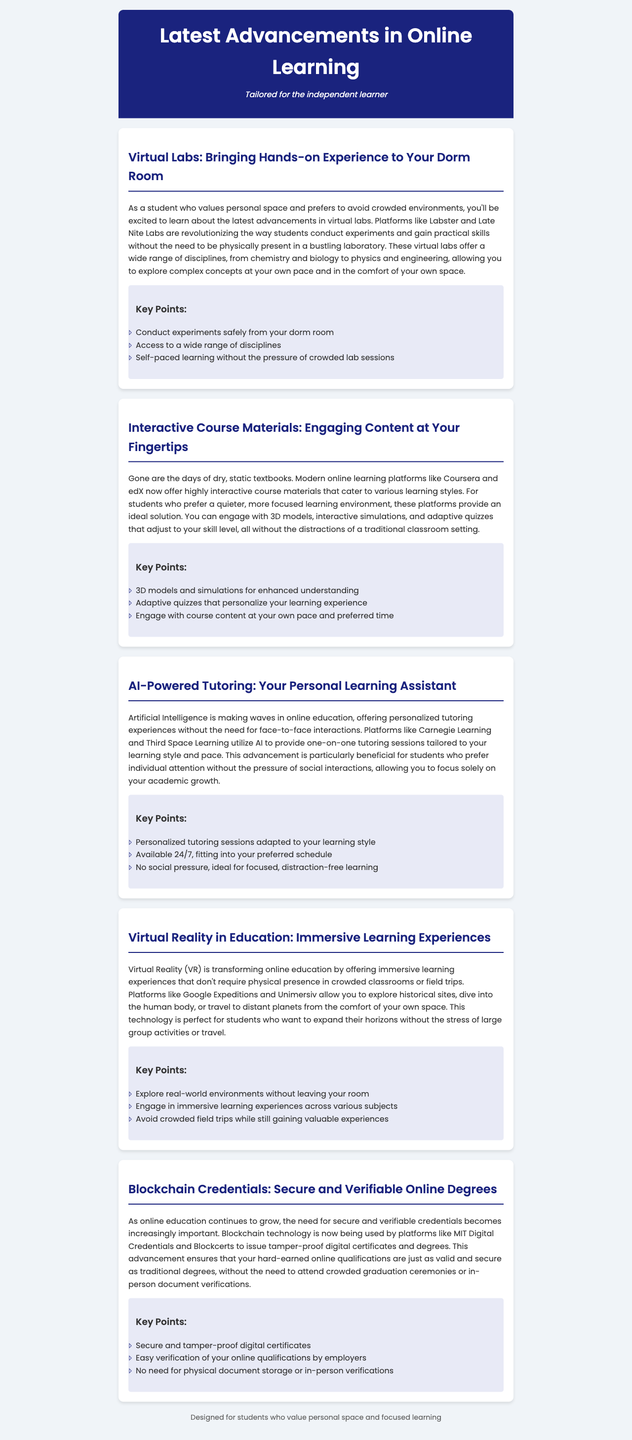What platforms are mentioned for virtual labs? The document lists Labster and Late Nite Labs as platforms for virtual labs.
Answer: Labster, Late Nite Labs What new technology is used for secure online degrees? The newsletter mentions blockchain technology for issuing secure and verifiable credentials.
Answer: Blockchain technology Which platforms offer interactive course materials? Coursera and edX are the platforms that provide interactive course materials.
Answer: Coursera, edX How does AI-powered tutoring benefit students? AI-powered tutoring allows for personalized sessions without face-to-face interactions, catering to individual learning styles.
Answer: Personalized sessions, no face-to-face interactions What is one key point about virtual reality in education? The key point is that it allows students to explore real-world environments without leaving their room.
Answer: Explore real-world environments without leaving your room What type of learning experience does virtual reality provide? Virtual reality offers immersive learning experiences.
Answer: Immersive learning experiences How many disciplines are accessible through virtual labs? The document states that a wide range of disciplines is accessible, specifically mentioning multiple fields.
Answer: A wide range of disciplines What aspect of course content does adaptive quizzes cater to? Adaptive quizzes personalize the learning experience by adjusting to the student's skill level.
Answer: Personalized learning experience 